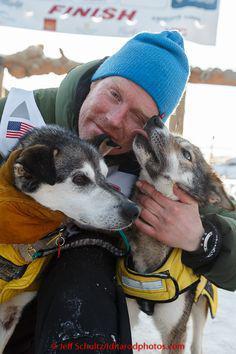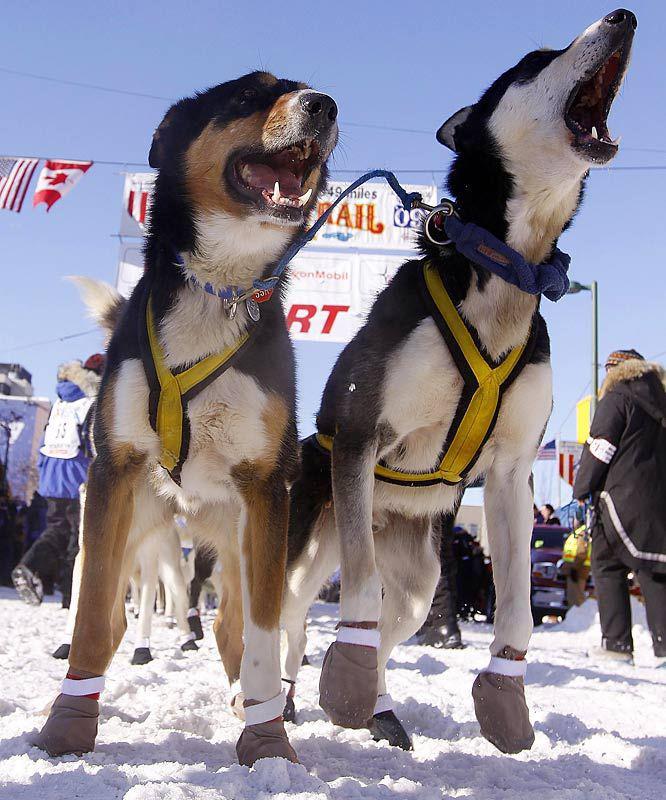The first image is the image on the left, the second image is the image on the right. Analyze the images presented: Is the assertion "A camera-facing person in winter clothing is hugging at least one dog to their front, and the dog's body is turned toward the camera too." valid? Answer yes or no. Yes. The first image is the image on the left, the second image is the image on the right. Assess this claim about the two images: "There is one person holding at least one dog.". Correct or not? Answer yes or no. Yes. 